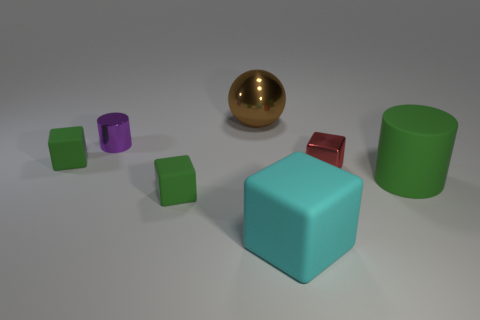The large rubber object that is the same shape as the red shiny object is what color? The large rubber object with the same cubic shape as the smaller red shiny one is a bright shade of cyan, visually distinct and easy to identify amid the assorted objects in the image. 